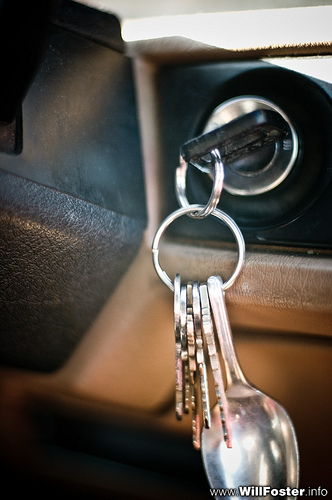<image>
Can you confirm if the key is in front of the key? No. The key is not in front of the key. The spatial positioning shows a different relationship between these objects. 